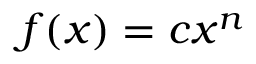Convert formula to latex. <formula><loc_0><loc_0><loc_500><loc_500>f ( x ) = c x ^ { n }</formula> 